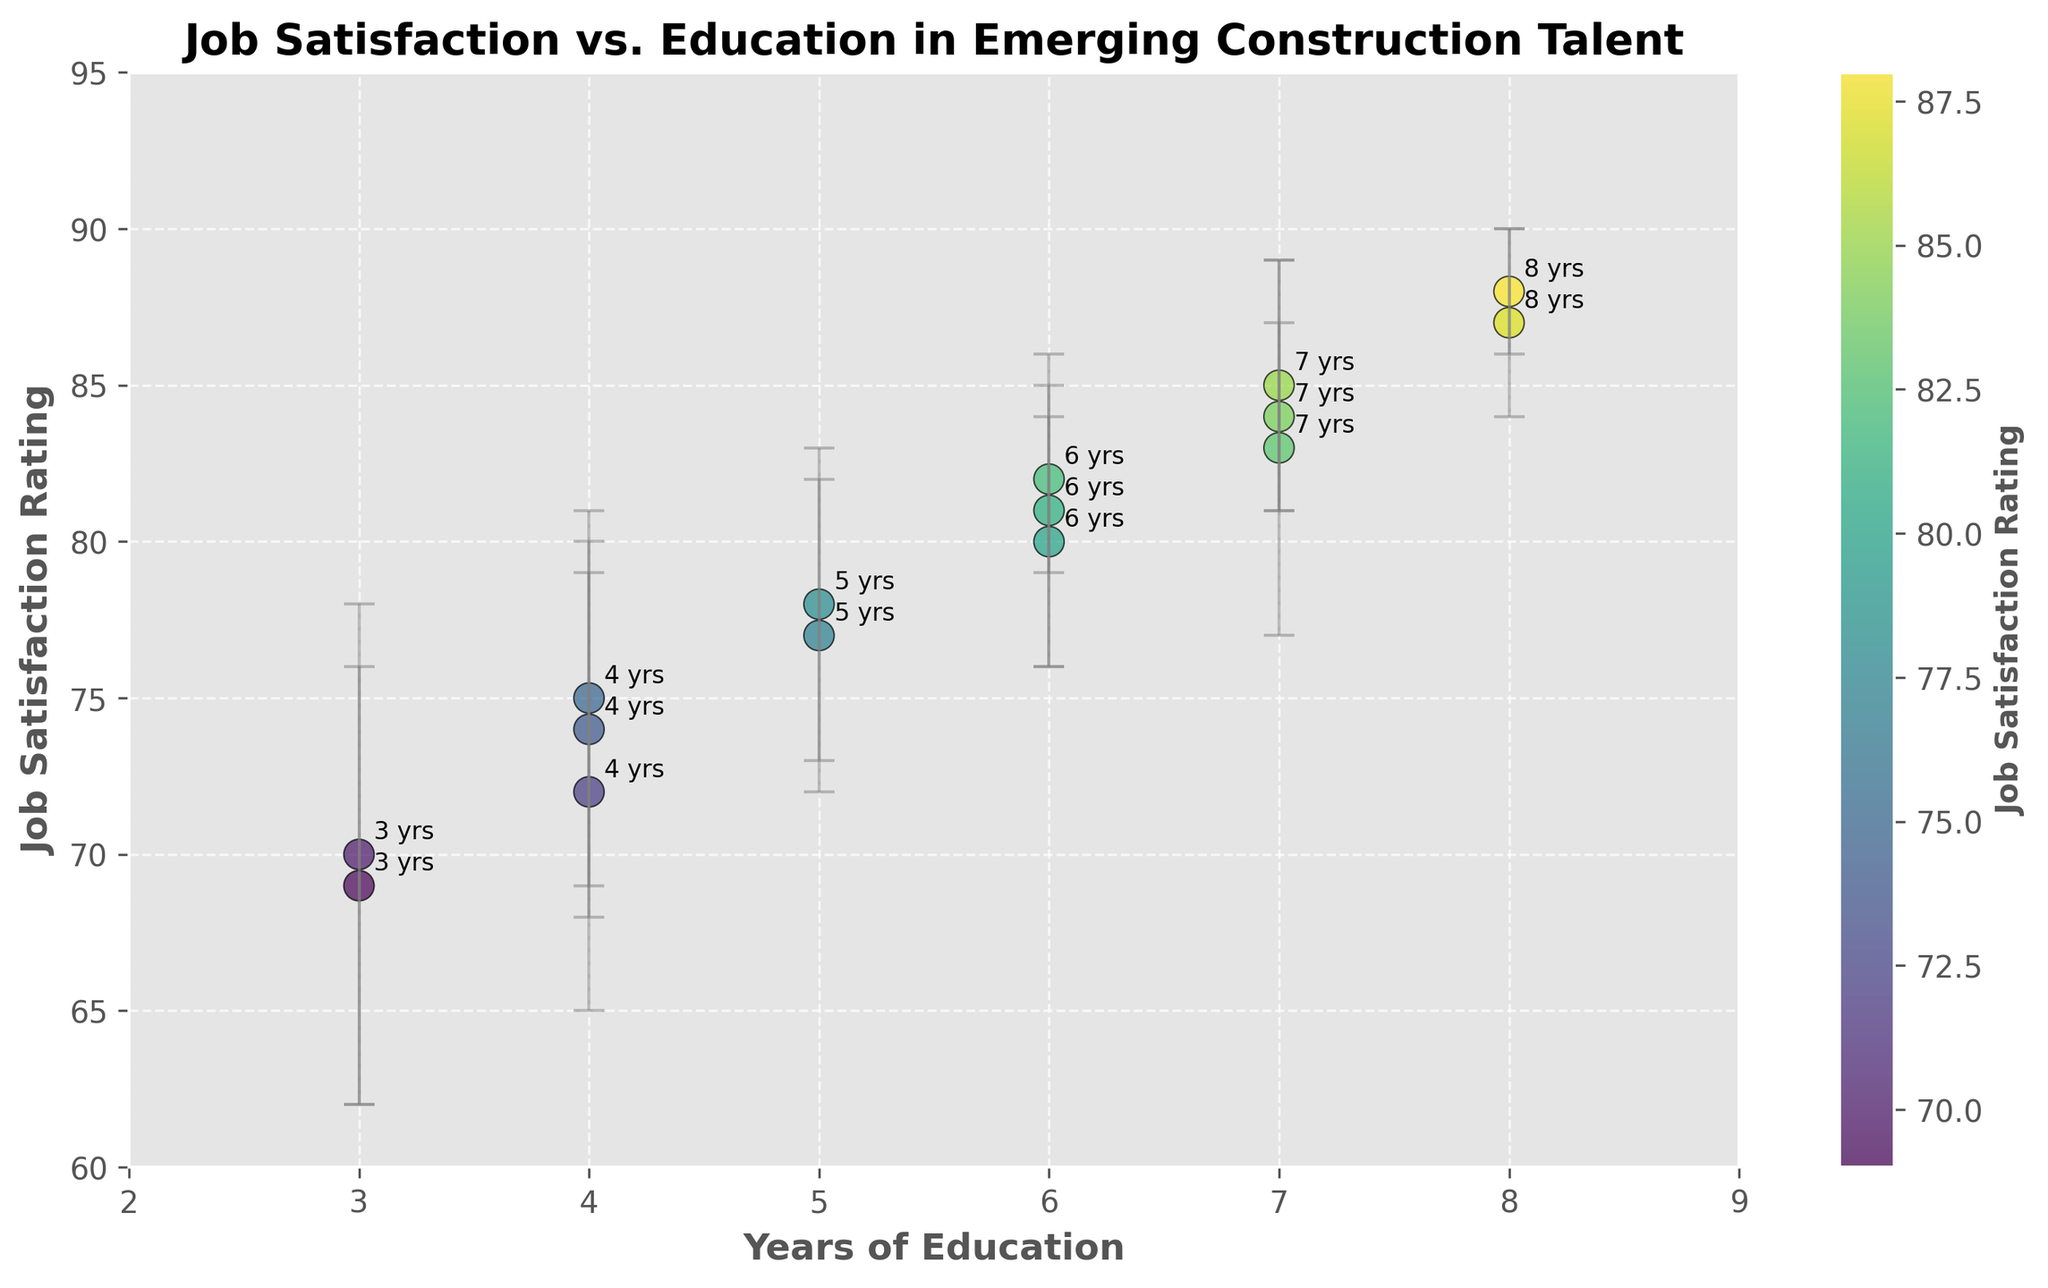Can you identify the title of the figure? The title of the figure is displayed at the top and is written in bold.
Answer: Job Satisfaction vs. Education in Emerging Construction Talent How many data points are displayed in the scatter plot? The plot features individual data points for each observation, marked by circles with varying colors. Counting these circles will give the number of data points.
Answer: 15 What is the range of the x-axis (Years of Education)? The x-axis range can be determined by noting the minimum and maximum values labeled on the axis.
Answer: 2 to 9 Which data point has the highest Job Satisfaction Rating? The data point with the highest Job Satisfaction Rating can be identified by finding the circle positioned highest on the y-axis.
Answer: The data point with 8 years of education and a rating of 88 What is the average Job Satisfaction Rating for individuals with 6 years of education? Calculate the Job Satisfaction Ratings for points with 6 years of education: (80 + 82 + 81). Sum these up and divide by the count of these points.
Answer: (80 + 82 + 81) / 3 = 81 Which years of education have the lowest average Job Satisfaction Rating? Calculate the average Job Satisfaction Rating for each number of years of education and compare these averages to find the lowest.
Answer: 3 years of education (average rating: (70 + 69) / 2 = 69.5) How does the Job Satisfaction Rating vary with years of education based on the error bars? Observe the error bars' span (standard deviations) at each level of education to ascertain how the satisfaction ratings fluctuate around the mean value. Higher variations indicate more fluctuation in ratings.
Answer: As years of education increase, variation generally decreases Between which years of education is the largest increase in Job Satisfaction Rating observed? Identify adjacent data points along the x-axis (years of education) and observe their y-values (Job Satisfaction Ratings) to see where the largest upward jump occurs.
Answer: From 3 to 4 years (an increase from 69 to 75) What is the median Job Satisfaction Rating for all data points? Arrange all Job Satisfaction Ratings in ascending order and find the middle value. For 15 data points, the median is the 8th value in the sorted list.
Answer: 80 Between those with 7 and 8 years of education, who shows greater variability in Job Satisfaction? Compare the lengths of the error bars for the data points with 7 and 8 years of education. Longer error bars indicate higher variability.
Answer: 7 years of education (higher variability with standard deviations of 4 and 6 compared to 2 and 3) 